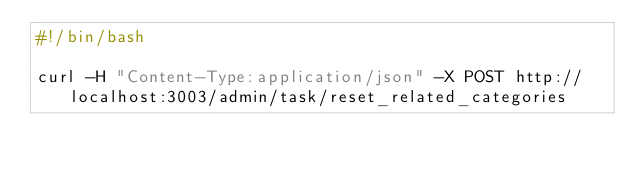<code> <loc_0><loc_0><loc_500><loc_500><_Bash_>#!/bin/bash

curl -H "Content-Type:application/json" -X POST http://localhost:3003/admin/task/reset_related_categories
</code> 